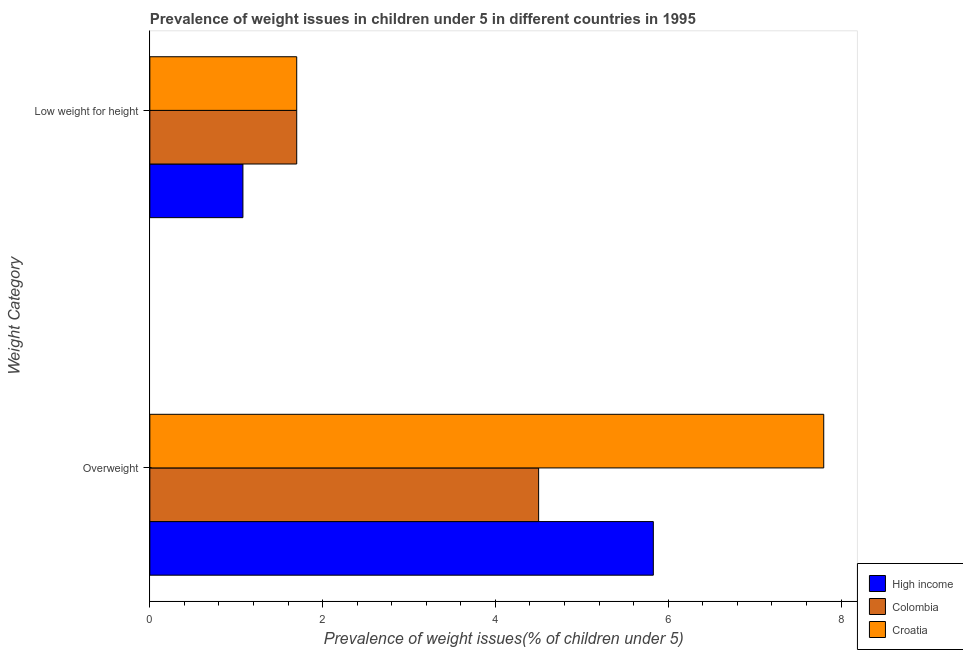How many groups of bars are there?
Your answer should be compact. 2. Are the number of bars on each tick of the Y-axis equal?
Provide a short and direct response. Yes. How many bars are there on the 1st tick from the top?
Ensure brevity in your answer.  3. What is the label of the 2nd group of bars from the top?
Your answer should be compact. Overweight. What is the percentage of overweight children in Croatia?
Your answer should be compact. 7.8. Across all countries, what is the maximum percentage of underweight children?
Provide a short and direct response. 1.7. Across all countries, what is the minimum percentage of underweight children?
Make the answer very short. 1.08. In which country was the percentage of overweight children maximum?
Offer a terse response. Croatia. What is the total percentage of overweight children in the graph?
Offer a terse response. 18.13. What is the difference between the percentage of overweight children in Croatia and that in Colombia?
Ensure brevity in your answer.  3.3. What is the difference between the percentage of underweight children in High income and the percentage of overweight children in Croatia?
Give a very brief answer. -6.72. What is the average percentage of overweight children per country?
Give a very brief answer. 6.04. What is the difference between the percentage of underweight children and percentage of overweight children in Colombia?
Give a very brief answer. -2.8. What is the ratio of the percentage of underweight children in Croatia to that in High income?
Make the answer very short. 1.58. Is the percentage of underweight children in High income less than that in Croatia?
Keep it short and to the point. Yes. In how many countries, is the percentage of overweight children greater than the average percentage of overweight children taken over all countries?
Your answer should be compact. 1. What does the 1st bar from the bottom in Overweight represents?
Provide a short and direct response. High income. Are all the bars in the graph horizontal?
Your answer should be very brief. Yes. How many countries are there in the graph?
Provide a succinct answer. 3. What is the difference between two consecutive major ticks on the X-axis?
Your answer should be compact. 2. Are the values on the major ticks of X-axis written in scientific E-notation?
Your answer should be very brief. No. Does the graph contain any zero values?
Your response must be concise. No. How many legend labels are there?
Keep it short and to the point. 3. What is the title of the graph?
Offer a very short reply. Prevalence of weight issues in children under 5 in different countries in 1995. Does "Burkina Faso" appear as one of the legend labels in the graph?
Offer a very short reply. No. What is the label or title of the X-axis?
Provide a short and direct response. Prevalence of weight issues(% of children under 5). What is the label or title of the Y-axis?
Make the answer very short. Weight Category. What is the Prevalence of weight issues(% of children under 5) in High income in Overweight?
Make the answer very short. 5.83. What is the Prevalence of weight issues(% of children under 5) of Colombia in Overweight?
Offer a terse response. 4.5. What is the Prevalence of weight issues(% of children under 5) of Croatia in Overweight?
Provide a short and direct response. 7.8. What is the Prevalence of weight issues(% of children under 5) of High income in Low weight for height?
Provide a succinct answer. 1.08. What is the Prevalence of weight issues(% of children under 5) in Colombia in Low weight for height?
Provide a short and direct response. 1.7. What is the Prevalence of weight issues(% of children under 5) of Croatia in Low weight for height?
Provide a succinct answer. 1.7. Across all Weight Category, what is the maximum Prevalence of weight issues(% of children under 5) of High income?
Your response must be concise. 5.83. Across all Weight Category, what is the maximum Prevalence of weight issues(% of children under 5) in Croatia?
Make the answer very short. 7.8. Across all Weight Category, what is the minimum Prevalence of weight issues(% of children under 5) in High income?
Provide a short and direct response. 1.08. Across all Weight Category, what is the minimum Prevalence of weight issues(% of children under 5) of Colombia?
Provide a short and direct response. 1.7. Across all Weight Category, what is the minimum Prevalence of weight issues(% of children under 5) of Croatia?
Give a very brief answer. 1.7. What is the total Prevalence of weight issues(% of children under 5) of High income in the graph?
Your answer should be compact. 6.9. What is the total Prevalence of weight issues(% of children under 5) in Colombia in the graph?
Provide a short and direct response. 6.2. What is the total Prevalence of weight issues(% of children under 5) in Croatia in the graph?
Make the answer very short. 9.5. What is the difference between the Prevalence of weight issues(% of children under 5) in High income in Overweight and that in Low weight for height?
Ensure brevity in your answer.  4.75. What is the difference between the Prevalence of weight issues(% of children under 5) of Colombia in Overweight and that in Low weight for height?
Ensure brevity in your answer.  2.8. What is the difference between the Prevalence of weight issues(% of children under 5) of High income in Overweight and the Prevalence of weight issues(% of children under 5) of Colombia in Low weight for height?
Make the answer very short. 4.13. What is the difference between the Prevalence of weight issues(% of children under 5) of High income in Overweight and the Prevalence of weight issues(% of children under 5) of Croatia in Low weight for height?
Your response must be concise. 4.13. What is the average Prevalence of weight issues(% of children under 5) of High income per Weight Category?
Provide a short and direct response. 3.45. What is the average Prevalence of weight issues(% of children under 5) in Colombia per Weight Category?
Make the answer very short. 3.1. What is the average Prevalence of weight issues(% of children under 5) of Croatia per Weight Category?
Your response must be concise. 4.75. What is the difference between the Prevalence of weight issues(% of children under 5) in High income and Prevalence of weight issues(% of children under 5) in Colombia in Overweight?
Make the answer very short. 1.33. What is the difference between the Prevalence of weight issues(% of children under 5) in High income and Prevalence of weight issues(% of children under 5) in Croatia in Overweight?
Offer a very short reply. -1.97. What is the difference between the Prevalence of weight issues(% of children under 5) in High income and Prevalence of weight issues(% of children under 5) in Colombia in Low weight for height?
Your answer should be very brief. -0.62. What is the difference between the Prevalence of weight issues(% of children under 5) in High income and Prevalence of weight issues(% of children under 5) in Croatia in Low weight for height?
Your answer should be compact. -0.62. What is the difference between the Prevalence of weight issues(% of children under 5) of Colombia and Prevalence of weight issues(% of children under 5) of Croatia in Low weight for height?
Offer a terse response. 0. What is the ratio of the Prevalence of weight issues(% of children under 5) of High income in Overweight to that in Low weight for height?
Your answer should be compact. 5.41. What is the ratio of the Prevalence of weight issues(% of children under 5) of Colombia in Overweight to that in Low weight for height?
Give a very brief answer. 2.65. What is the ratio of the Prevalence of weight issues(% of children under 5) of Croatia in Overweight to that in Low weight for height?
Give a very brief answer. 4.59. What is the difference between the highest and the second highest Prevalence of weight issues(% of children under 5) of High income?
Your response must be concise. 4.75. What is the difference between the highest and the lowest Prevalence of weight issues(% of children under 5) of High income?
Offer a very short reply. 4.75. What is the difference between the highest and the lowest Prevalence of weight issues(% of children under 5) in Colombia?
Offer a terse response. 2.8. 